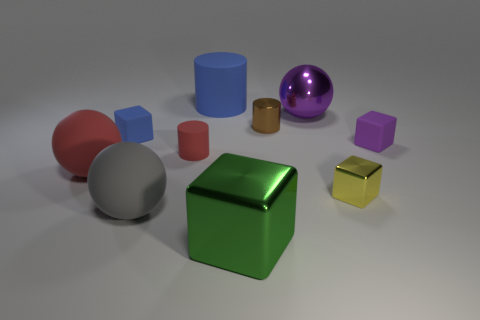Subtract 1 cubes. How many cubes are left? 3 Subtract all purple blocks. Subtract all gray cylinders. How many blocks are left? 3 Subtract all balls. How many objects are left? 7 Add 7 purple matte blocks. How many purple matte blocks are left? 8 Add 1 tiny rubber cylinders. How many tiny rubber cylinders exist? 2 Subtract 0 brown balls. How many objects are left? 10 Subtract all large gray matte balls. Subtract all gray rubber objects. How many objects are left? 8 